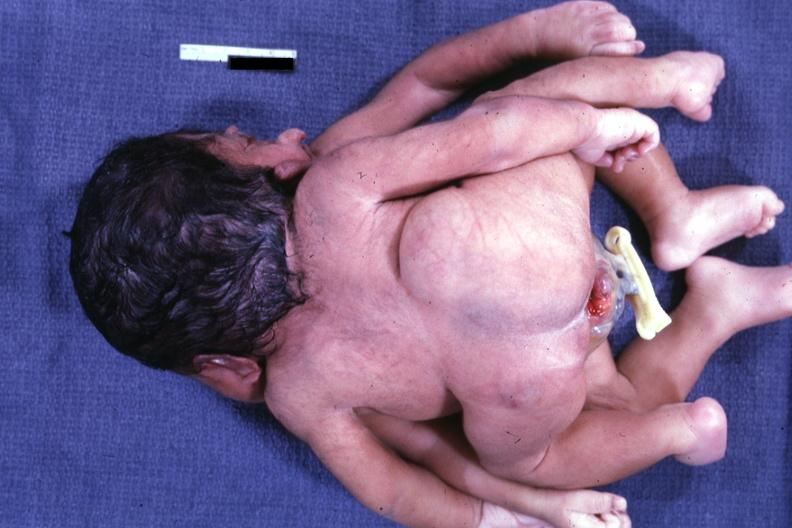does this image show view of twin joined at head and chest?
Answer the question using a single word or phrase. Yes 